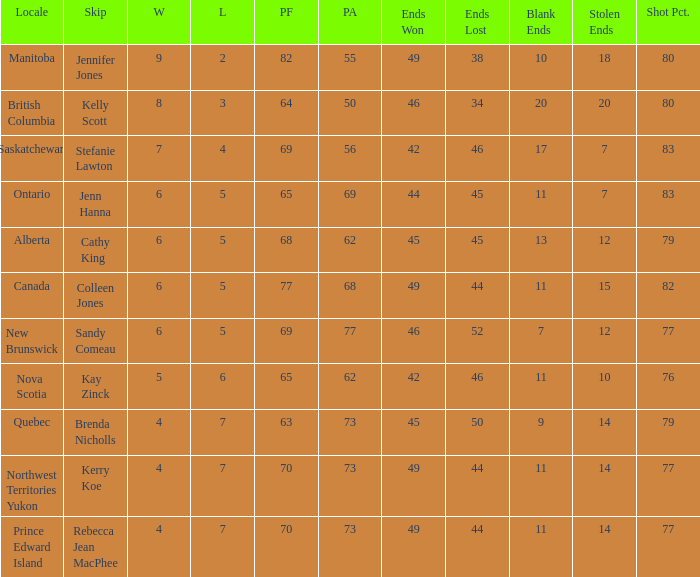What is the PA when the skip is Colleen Jones? 68.0. 